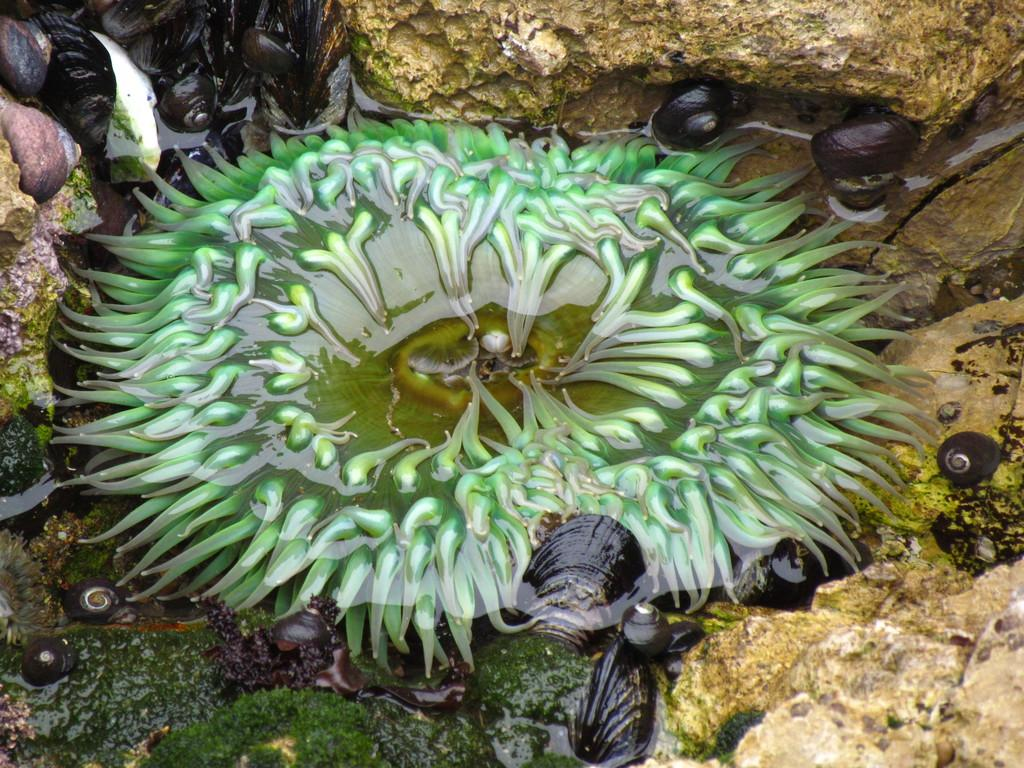What type of plant can be seen in the image? There is an aquatic plant in the image. What other living organisms are present in the image? There are snails in the image. What is the green substance visible in the image? There is algae in the image. What is the primary element in the image? There is water visible in the image. What type of inanimate objects can be seen in the image? There are rocks in the image. What type of protest is taking place in the image? There is no protest present in the image; it features an aquatic plant, snails, algae, water, and rocks. Can you describe the trail that the snails are following in the image? There is no trail visible in the image; the snails are simply present among the aquatic plant, algae, water, and rocks. 